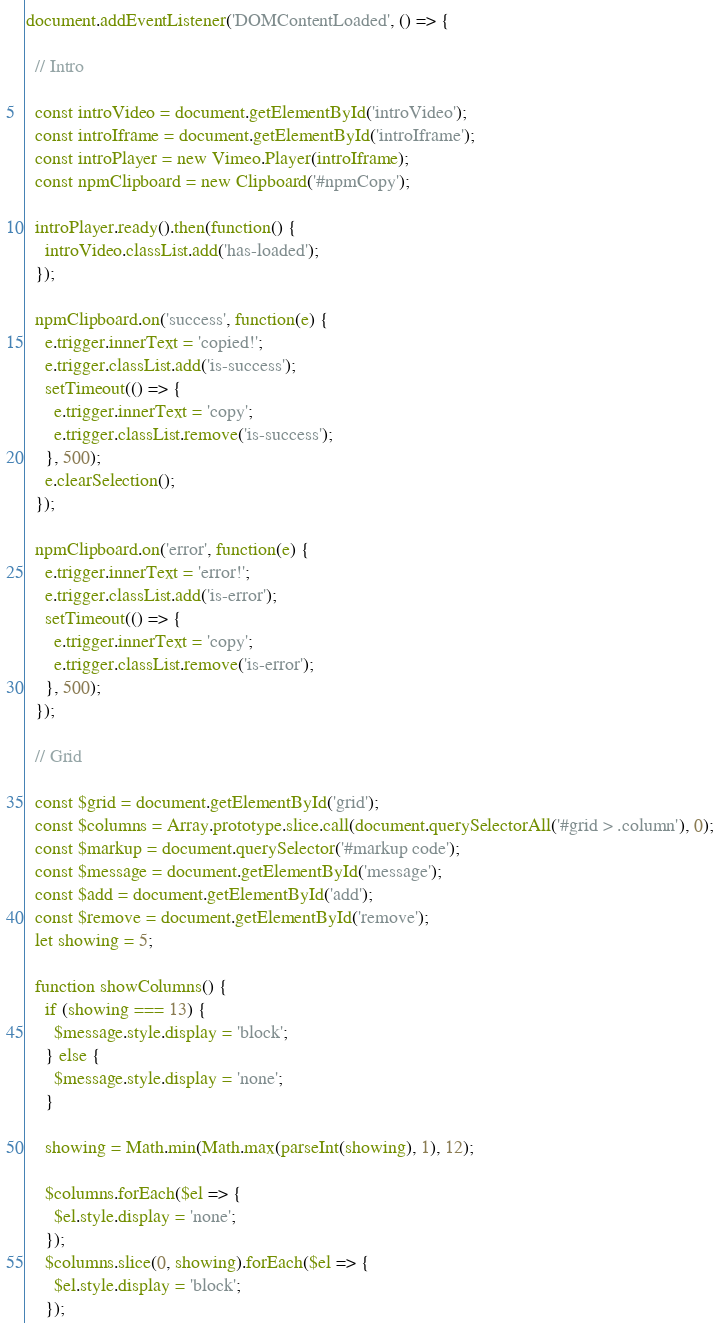<code> <loc_0><loc_0><loc_500><loc_500><_JavaScript_>document.addEventListener('DOMContentLoaded', () => {

  // Intro

  const introVideo = document.getElementById('introVideo');
  const introIframe = document.getElementById('introIframe');
  const introPlayer = new Vimeo.Player(introIframe);
  const npmClipboard = new Clipboard('#npmCopy');

  introPlayer.ready().then(function() {
    introVideo.classList.add('has-loaded');
  });

  npmClipboard.on('success', function(e) {
    e.trigger.innerText = 'copied!';
    e.trigger.classList.add('is-success');
    setTimeout(() => {
      e.trigger.innerText = 'copy';
      e.trigger.classList.remove('is-success');
    }, 500);
    e.clearSelection();
  });

  npmClipboard.on('error', function(e) {
    e.trigger.innerText = 'error!';
    e.trigger.classList.add('is-error');
    setTimeout(() => {
      e.trigger.innerText = 'copy';
      e.trigger.classList.remove('is-error');
    }, 500);
  });

  // Grid

  const $grid = document.getElementById('grid');
  const $columns = Array.prototype.slice.call(document.querySelectorAll('#grid > .column'), 0);
  const $markup = document.querySelector('#markup code');
  const $message = document.getElementById('message');
  const $add = document.getElementById('add');
  const $remove = document.getElementById('remove');
  let showing = 5;

  function showColumns() {
    if (showing === 13) {
      $message.style.display = 'block';
    } else {
      $message.style.display = 'none';
    }

    showing = Math.min(Math.max(parseInt(showing), 1), 12);

    $columns.forEach($el => {
      $el.style.display = 'none';
    });
    $columns.slice(0, showing).forEach($el => {
      $el.style.display = 'block';
    });
</code> 